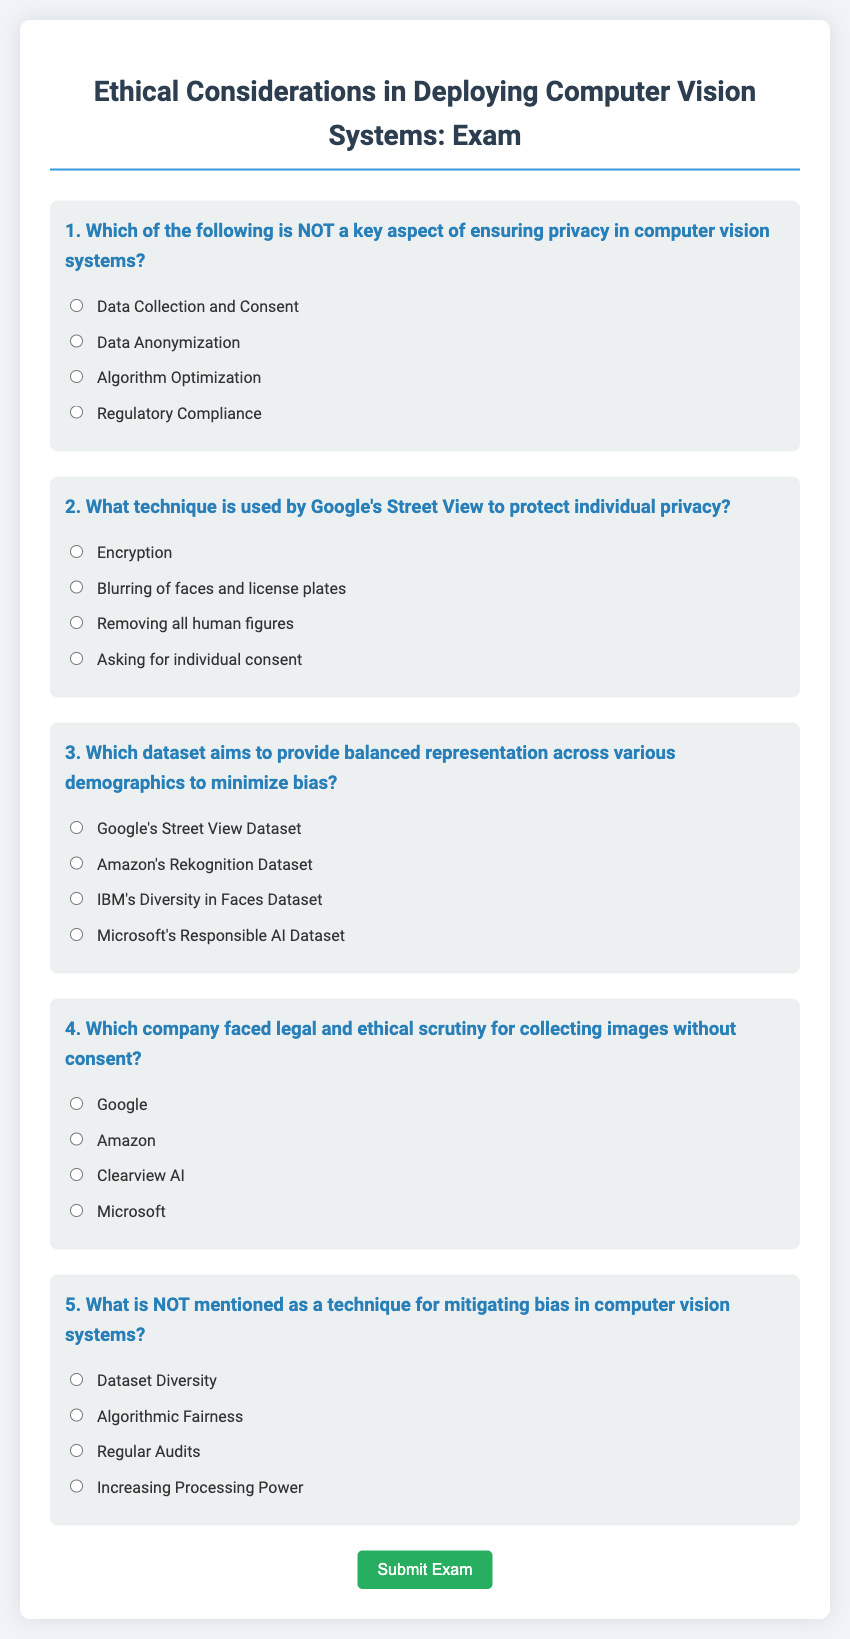What is the title of the exam? The title is prominently displayed at the top of the document and reads "Ethical Considerations in Deploying Computer Vision Systems: Exam."
Answer: Ethical Considerations in Deploying Computer Vision Systems: Exam How many questions are in the exam? The document outlines five unique exam questions addressing ethical considerations in computer vision systems.
Answer: 5 What technique does Google's Street View use to protect individual privacy? The exam question specifically asks for the technique used, and the correct answer is stated in the options provided as "Blurring of faces and license plates."
Answer: Blurring of faces and license plates Which company faced scrutiny for collecting images without consent? This question is included in the document, and it explicitly lists "Clearview AI" as the company in question.
Answer: Clearview AI What is NOT mentioned as a technique for mitigating bias? The options include various techniques, and the correct answer indicating what is NOT mentioned is "Increasing Processing Power."
Answer: Increasing Processing Power What is a key aspect of ensuring privacy in computer vision systems? The document presents a question that covers various aspects, with data collection and consent being identified as NOT a key aspect in one of the options.
Answer: Algorithm Optimization 